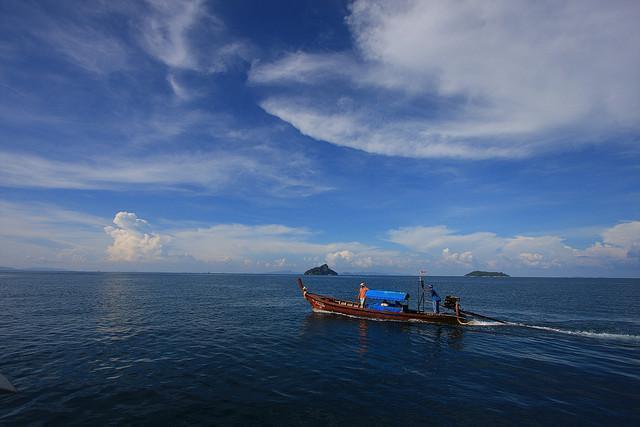What propels this craft forward?
From the following four choices, select the correct answer to address the question.
Options: Oars, sails, motor, wind. Motor. 